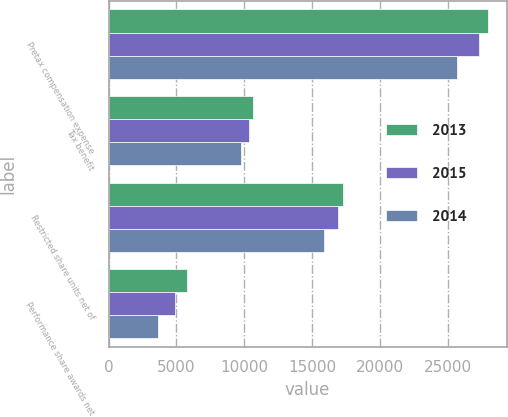Convert chart. <chart><loc_0><loc_0><loc_500><loc_500><stacked_bar_chart><ecel><fcel>Pretax compensation expense<fcel>Tax benefit<fcel>Restricted share units net of<fcel>Performance share awards net<nl><fcel>2013<fcel>27898<fcel>10629<fcel>17269<fcel>5775<nl><fcel>2015<fcel>27256<fcel>10360<fcel>16896<fcel>4886<nl><fcel>2014<fcel>25606<fcel>9769<fcel>15837<fcel>3675<nl></chart> 